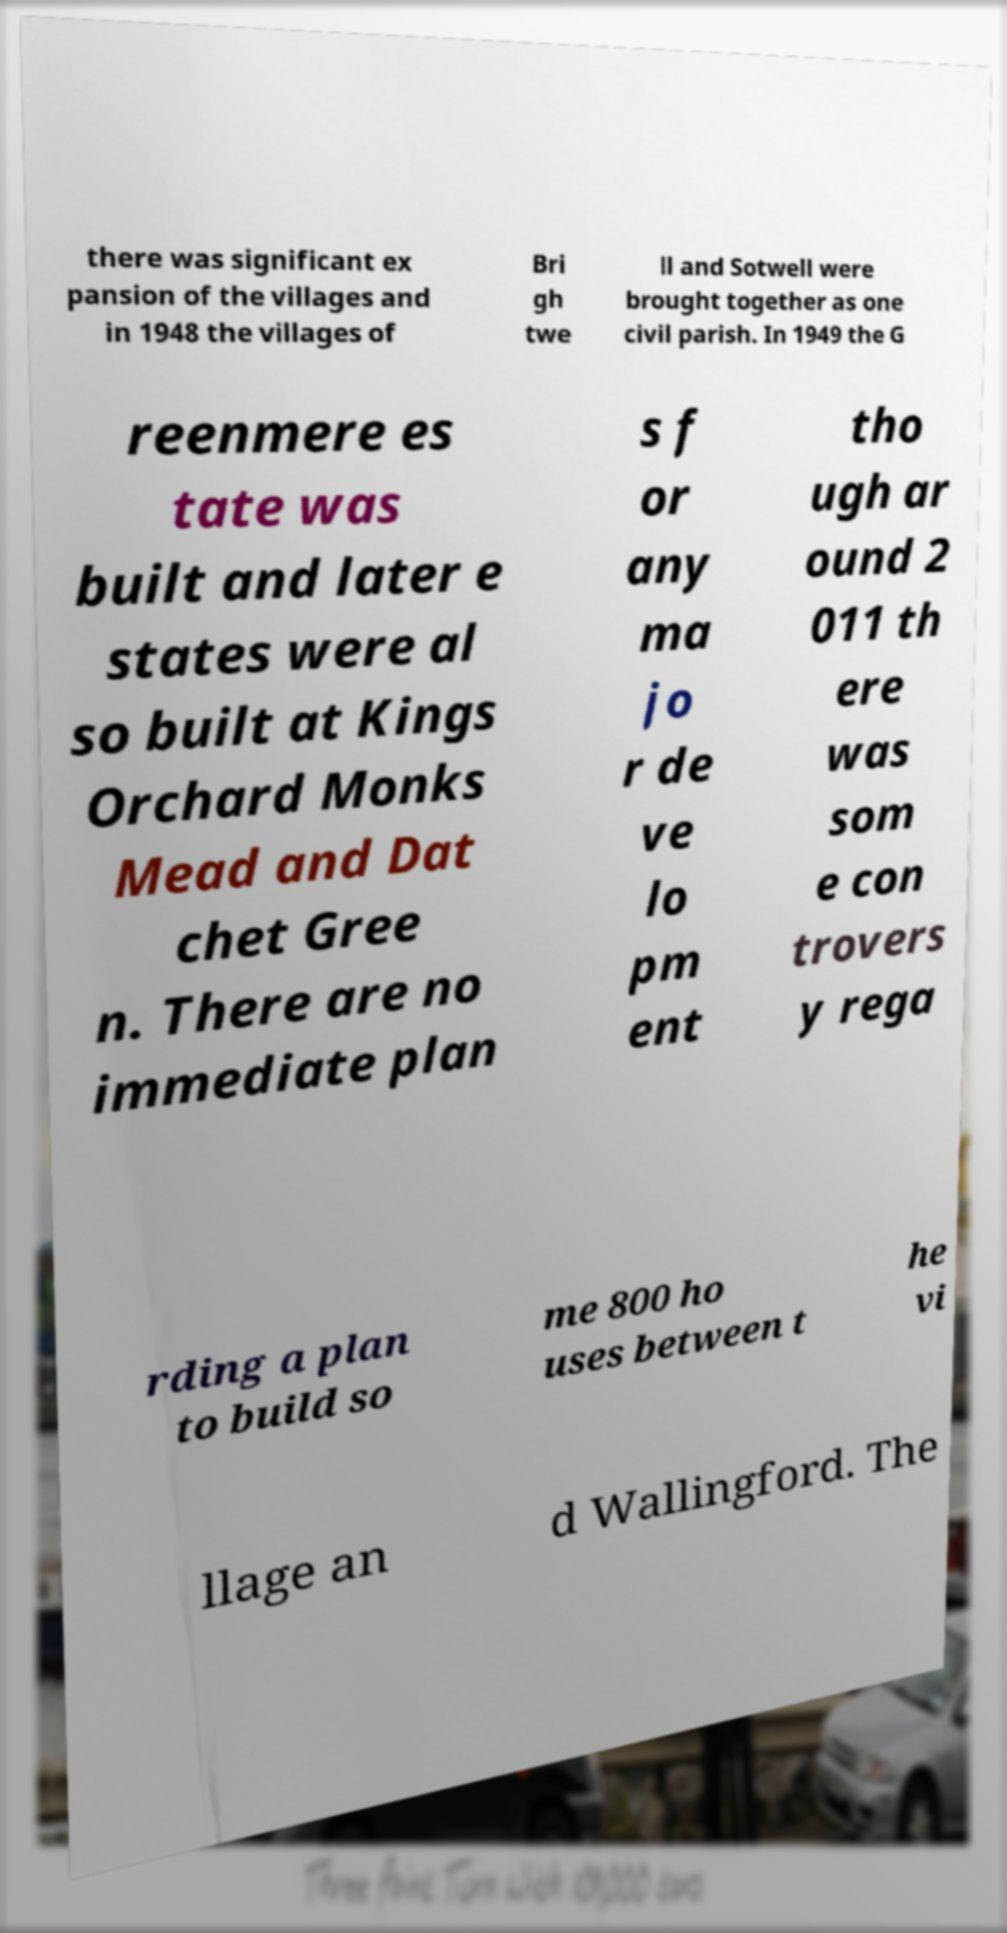What messages or text are displayed in this image? I need them in a readable, typed format. there was significant ex pansion of the villages and in 1948 the villages of Bri gh twe ll and Sotwell were brought together as one civil parish. In 1949 the G reenmere es tate was built and later e states were al so built at Kings Orchard Monks Mead and Dat chet Gree n. There are no immediate plan s f or any ma jo r de ve lo pm ent tho ugh ar ound 2 011 th ere was som e con trovers y rega rding a plan to build so me 800 ho uses between t he vi llage an d Wallingford. The 